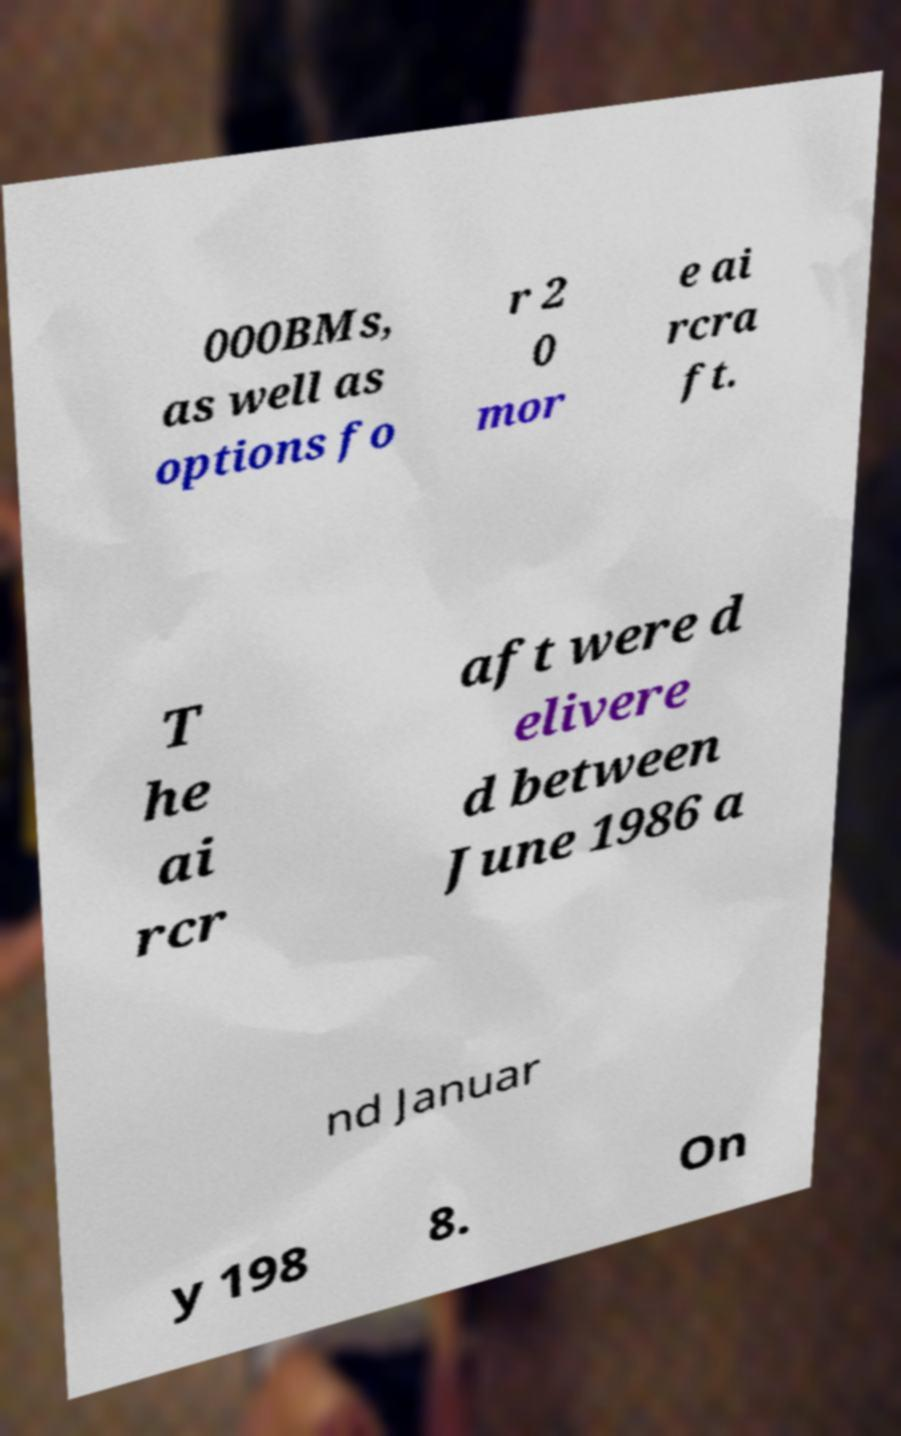Could you extract and type out the text from this image? 000BMs, as well as options fo r 2 0 mor e ai rcra ft. T he ai rcr aft were d elivere d between June 1986 a nd Januar y 198 8. On 